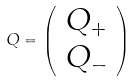<formula> <loc_0><loc_0><loc_500><loc_500>Q = \left ( \begin{array} { c } Q _ { + } \\ Q _ { - } \end{array} \right )</formula> 